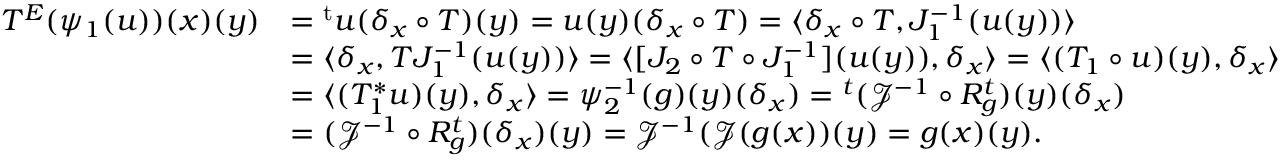Convert formula to latex. <formula><loc_0><loc_0><loc_500><loc_500>\begin{array} { r l } { T ^ { E } ( \psi _ { 1 } ( u ) ) ( x ) ( y ) } & { = { ^ { t } u } ( \delta _ { x } \circ T ) ( y ) = u ( y ) ( \delta _ { x } \circ T ) = \langle \delta _ { x } \circ T , J _ { 1 } ^ { - 1 } ( u ( y ) ) \rangle } \\ & { = \langle \delta _ { x } , T J _ { 1 } ^ { - 1 } ( u ( y ) ) \rangle = \langle [ J _ { 2 } \circ T \circ J _ { 1 } ^ { - 1 } ] ( u ( y ) ) , \delta _ { x } \rangle = \langle ( T _ { 1 } \circ u ) ( y ) , \delta _ { x } \rangle } \\ & { = \langle ( T _ { 1 } ^ { \ast } u ) ( y ) , \delta _ { x } \rangle = \psi _ { 2 } ^ { - 1 } ( g ) ( y ) ( \delta _ { x } ) = { ^ { t } ( \mathcal { J } ^ { - 1 } \circ R _ { g } ^ { t } ) } ( y ) ( \delta _ { x } ) } \\ & { = ( \mathcal { J } ^ { - 1 } \circ R _ { g } ^ { t } ) ( \delta _ { x } ) ( y ) = \mathcal { J } ^ { - 1 } ( \mathcal { J } ( g ( x ) ) ( y ) = g ( x ) ( y ) . } \end{array}</formula> 